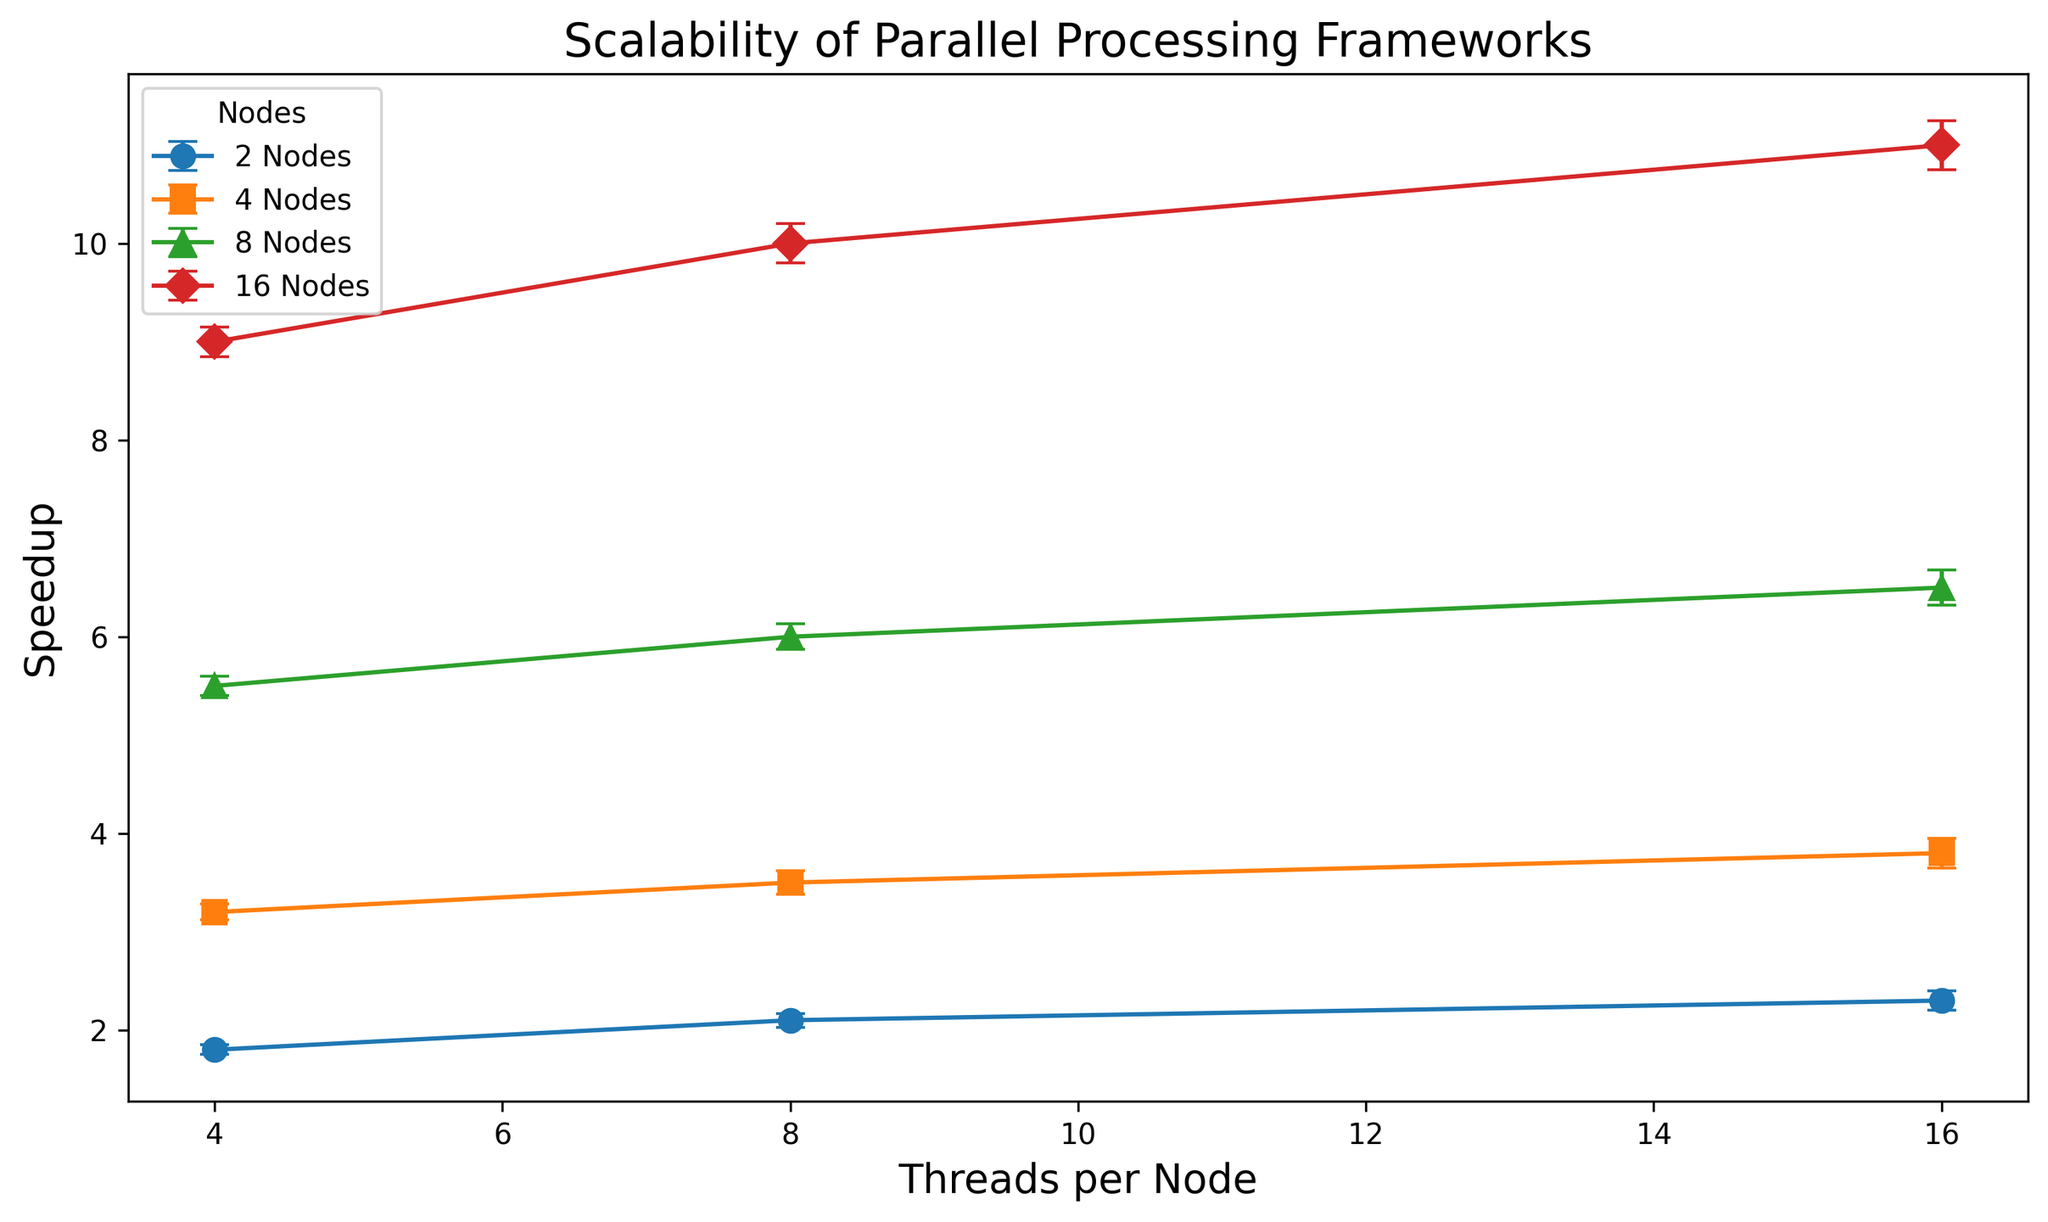What pattern of speedup do we see when increasing the number of threads per node for 2 nodes? Starting from 4 threads per node, the speedup is 1.8, then increasing to 8 and 16 threads per node, the speedup values are 2.1 and 2.3, respectively. This shows a positive trend in speedup with increasing threads per node for 2 nodes.
Answer: Increasing For 16 nodes, what can be said about the speedup when moving from 4 to 8 to 16 threads per node? For 16 nodes, the speedup values for 4, 8, and 16 threads per node are 9.0, 10.0, and 11.0, respectively, indicating a consistent increase in speedup with more threads.
Answer: Consistent increase Which node configuration shows the largest standard error in speedup? The largest standard error value of 0.25 appears for the 16 nodes with 16 threads per node.
Answer: 16 nodes with 16 threads Is the speedup for 8 nodes and 8 threads per node greater than the speedup for 4 nodes and 16 threads per node? The speedup for 8 nodes and 8 threads per node is 6.0, while for 4 nodes and 16 threads per node, it is 3.8. Therefore, the former is greater.
Answer: Yes What is the difference in speedup between 16 nodes with 16 threads per node and 8 nodes with 4 threads per node? The speedup for 16 nodes with 16 threads per node is 11.0, and for 8 nodes with 4 threads per node, it is 5.5. The difference is 11.0 - 5.5 = 5.5.
Answer: 5.5 How does the standard error vary with an increased number of nodes for the 16 threads per node configuration? The standard errors for 16 threads per node and different numbers of nodes are: 2 nodes (0.1), 4 nodes (0.15), 8 nodes (0.18), and 16 nodes (0.25). This shows an increasing trend in standard error with more nodes.
Answer: Increasing Between 4 and 16 nodes, which configuration achieves the best speedup with 8 threads per node? For 8 threads per node, 4 nodes achieve a speedup of 3.5, and 16 nodes achieve a speedup of 10. Hence, 16 nodes have the best speedup.
Answer: 16 nodes If you average the speedup values for 8 threads per node across all node configurations, what is the result? The speedup values for 8 threads per node are: 2.1 (2 nodes), 3.5 (4 nodes), 6.0 (8 nodes), and 10.0 (16 nodes). Their average is (2.1 + 3.5 + 6.0 + 10.0) / 4 = 21.6 / 4 = 5.4.
Answer: 5.4 What can be stated about the overall trend in speedup as both the number of nodes and threads per node increase? With both increasing nodes and threads per node, the speedup generally increases, demonstrating that higher parallel processing resources can substantially improve performance.
Answer: Generally increases 